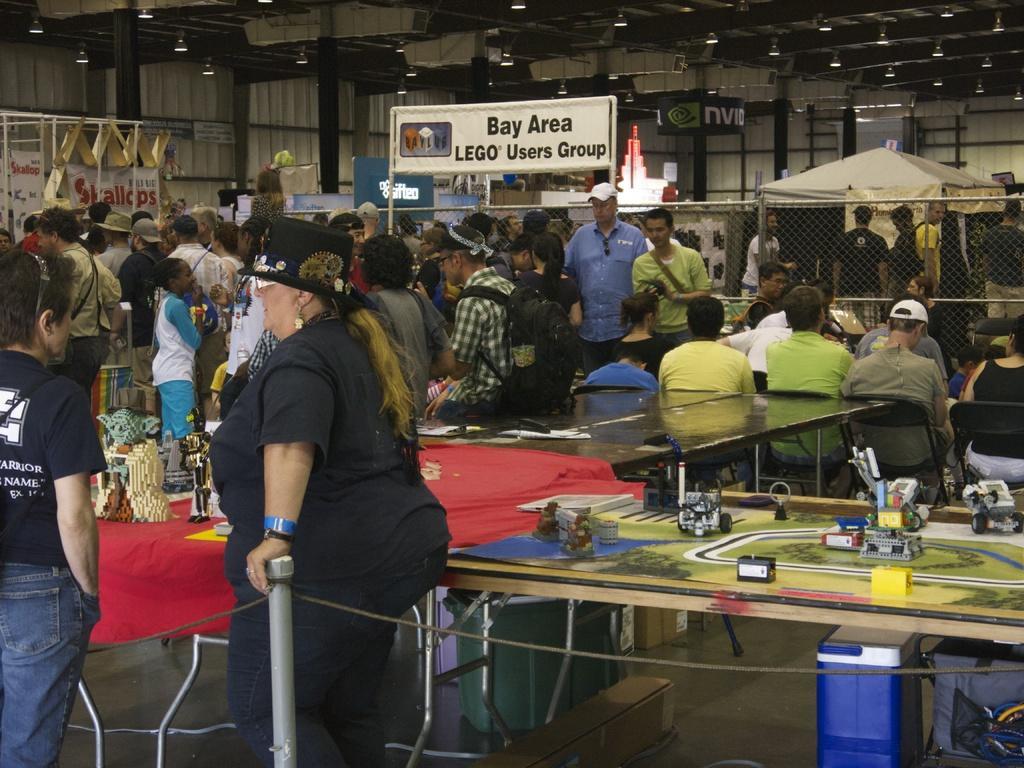Describe this image in one or two sentences. This picture describes about group of people, few are seated on the chairs and few are standing, in the middle of the image we can find few toys, miniatures and other things on the tables, in the background we can find few metal rods, hoardings, fence, lights and a tent, and also we can see a cable and a box. 